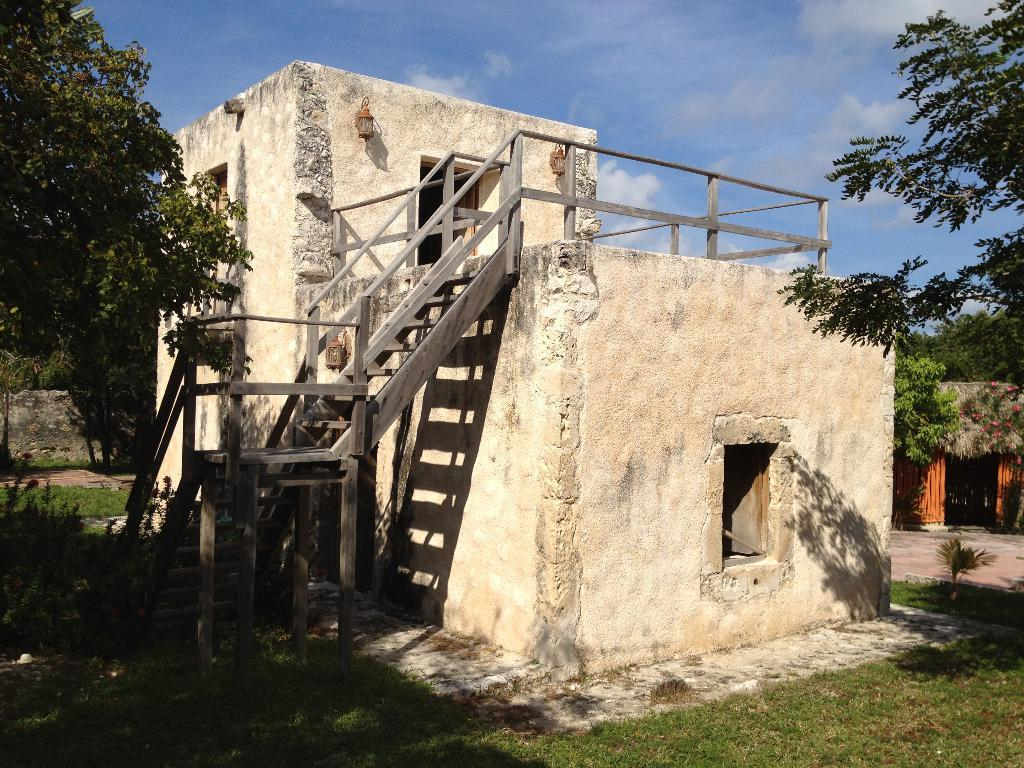What is the main subject of the image? The main subject of the image is the buildings at the center. What is in front of the buildings? There is a grass surface in front of the buildings. What can be seen in the background of the image? In the background of the image, there are plants, trees, and the sky. What type of story is being told by the band in the image? There is no band present in the image, so no story is being told by a band. 